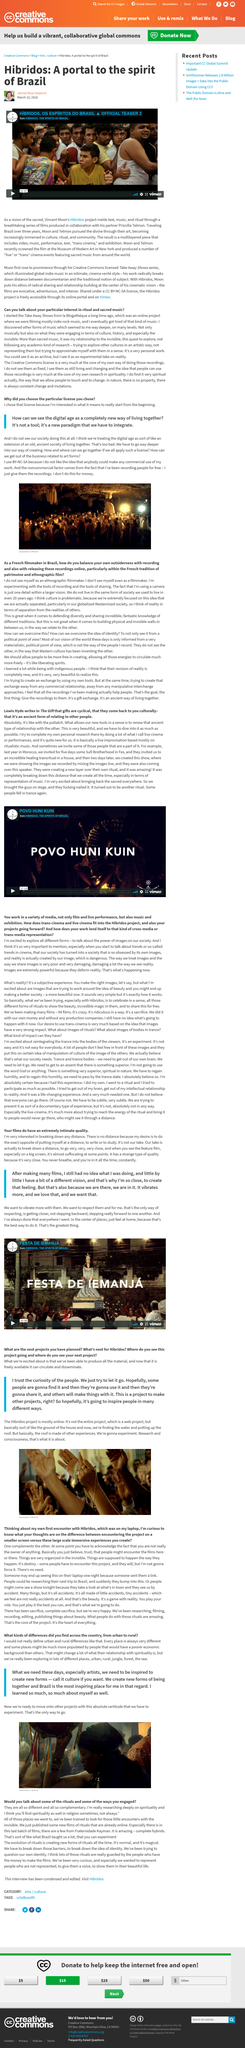Specify some key components in this picture. Vincent Moon's project is called "Hibridos. Vincent Moon's collaborative partner for the project is Priscilla Telmon. It is known that Moon and Telmon recently screened a film in New York in the year 2018. 